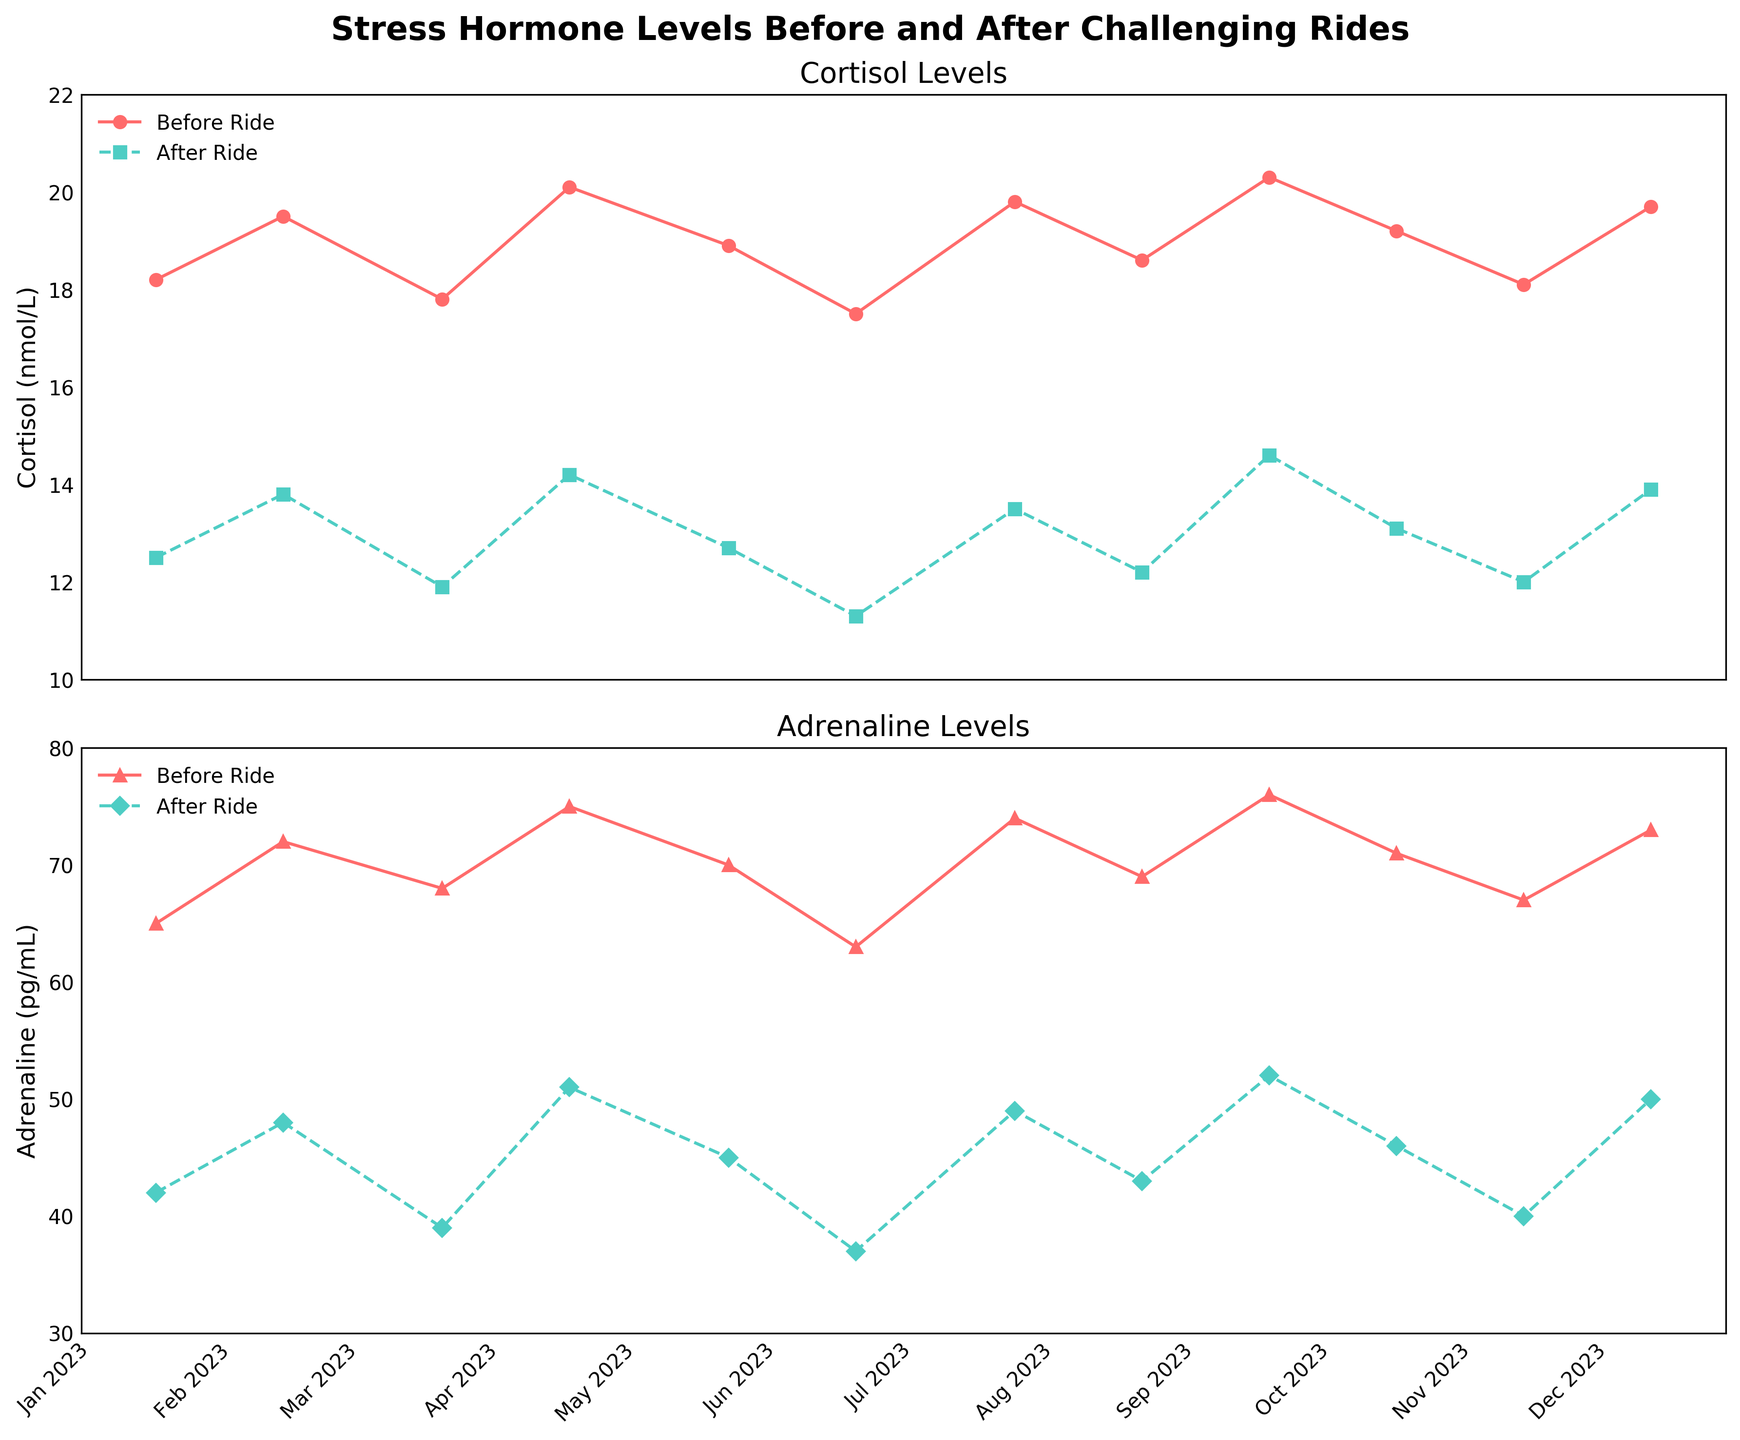What's the trend in cortisol levels before and after the rides over the 6-month period? By looking at the plotted lines, observe that the cortisol levels before rides slightly fluctuate but don't show a strong upward or downward trend. After rides, the cortisol levels consistently drop lower compared to before rides, maintaining a trend of stress reduction.
Answer: There is a consistent reduction in cortisol levels after rides Which ride had the largest decrease in cortisol levels? Calculate the difference between the "Before Ride" and "After Ride" cortisol levels for each ride. The ride on "2023-09-17" shows the largest decrease, where cortisol dropped from 20.3 nmol/L to 14.6 nmol/L, a difference of 5.7 nmol/L.
Answer: 2023-09-17 During which month did the adrenaline levels after the ride drop below 40 pg/mL? Look at the plotted adrenaline levels after the rides. The only month where the level drops below 40 pg/mL is on "2023-06-18" with a value of 37 pg/mL.
Answer: 2023-06-18 What is the average cortisol level before rides over the 6-month period? Add up the cortisol levels before the rides for each month and divide by the number of months: (18.2 + 19.5 + 17.8 + 20.1 + 18.9 + 17.5) / 6 = 18.67 nmol/L.
Answer: 18.67 nmol/L Compare the adrenaline levels before and after rides in terms of which are generally higher. By comparing the plotted lines for before and after rides, it is clear that the adrenaline levels before rides are consistently higher than those after the rides.
Answer: Before rides Identify which month shows the smallest difference in cortisol levels before and after rides. By calculating the difference for each month, the smallest difference is in "2023-11-12" with cortisol levels before the ride at 18.1 nmol/L and after the ride at 12 nmol/L, resulting in a difference of 6.1 nmol/L.
Answer: 2023-11-12 How many months experienced a decrease of over 5 nmol/L in cortisol levels after the rides? Go through each month and calculate the differences. Months with differences over 5 nmol/L are: "2023-09-17" (5.7 nmol/L), "2023-11-12" (6.1 nmol/L). Thus, two months experienced decreases over 5 nmol/L.
Answer: 2 months During which month is the difference between before and after adrenaline levels the largest? Calculate the difference for each month. The largest difference occurs in "2023-09-17" where adrenaline levels dropped from 76 pg/mL before the ride to 52 pg/mL after the ride, a difference of 24 pg/mL.
Answer: 2023-09-17 When was the highest cortisol level recorded before the ride, and how did it compare to after the ride on the same day? The highest cortisol level before the ride was recorded on "2023-09-17" with a value of 20.3 nmol/L. On the same day, the level after the ride was 14.6 nmol/L. Thus, there was a decrease of 5.7 nmol/L.
Answer: 2023-09-17 with a decrease of 5.7 nmol/L 